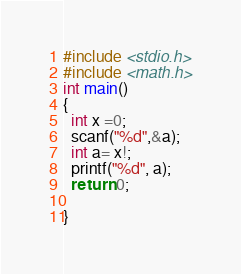Convert code to text. <code><loc_0><loc_0><loc_500><loc_500><_C_>#include <stdio.h>
#include <math.h>
int main()
{
  int x =0;
  scanf("%d",&a);
  int a= x!;
  printf("%d", a);
  return 0;
  
}</code> 